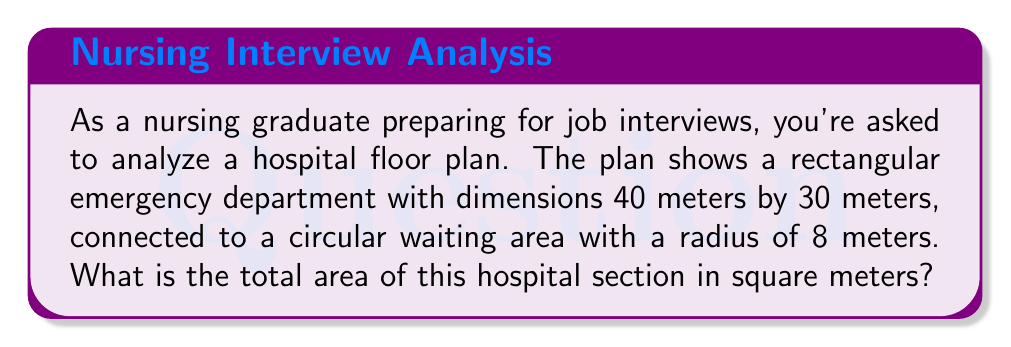Give your solution to this math problem. To solve this problem, we need to calculate the areas of the rectangular emergency department and the circular waiting area separately, then add them together.

1. Calculate the area of the rectangular emergency department:
   $$ A_{rectangle} = length \times width $$
   $$ A_{rectangle} = 40 \text{ m} \times 30 \text{ m} = 1200 \text{ m}^2 $$

2. Calculate the area of the circular waiting area:
   $$ A_{circle} = \pi r^2 $$
   $$ A_{circle} = \pi \times (8 \text{ m})^2 = 64\pi \text{ m}^2 $$

3. Add the two areas together:
   $$ A_{total} = A_{rectangle} + A_{circle} $$
   $$ A_{total} = 1200 \text{ m}^2 + 64\pi \text{ m}^2 $$
   $$ A_{total} = 1200 + 201.06 = 1401.06 \text{ m}^2 $$

The total area is approximately 1401.06 square meters.
Answer: $1401.06 \text{ m}^2$ 